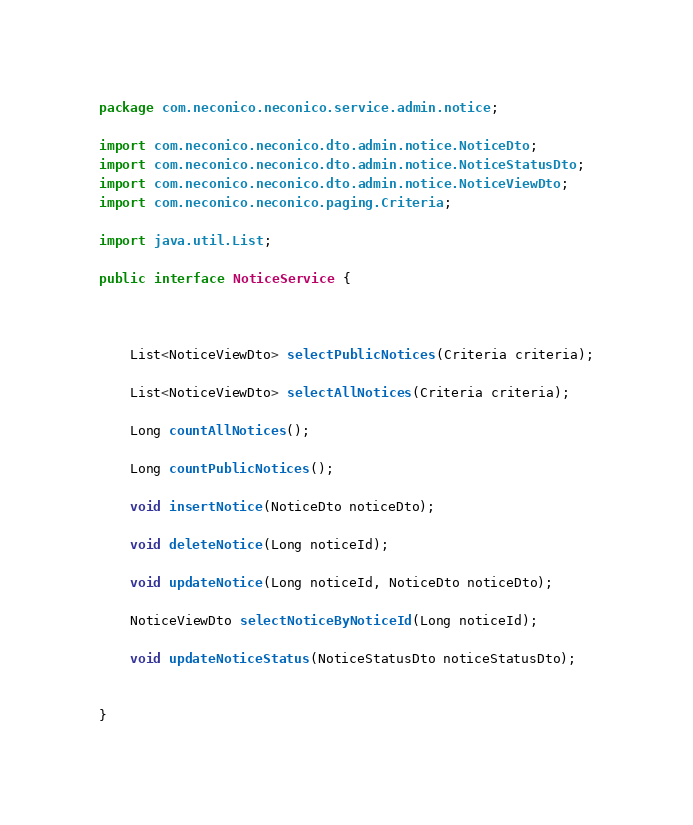<code> <loc_0><loc_0><loc_500><loc_500><_Java_>package com.neconico.neconico.service.admin.notice;

import com.neconico.neconico.dto.admin.notice.NoticeDto;
import com.neconico.neconico.dto.admin.notice.NoticeStatusDto;
import com.neconico.neconico.dto.admin.notice.NoticeViewDto;
import com.neconico.neconico.paging.Criteria;

import java.util.List;

public interface NoticeService {



    List<NoticeViewDto> selectPublicNotices(Criteria criteria);

    List<NoticeViewDto> selectAllNotices(Criteria criteria);

    Long countAllNotices();

    Long countPublicNotices();

    void insertNotice(NoticeDto noticeDto);

    void deleteNotice(Long noticeId);

    void updateNotice(Long noticeId, NoticeDto noticeDto);

    NoticeViewDto selectNoticeByNoticeId(Long noticeId);

    void updateNoticeStatus(NoticeStatusDto noticeStatusDto);


}
</code> 